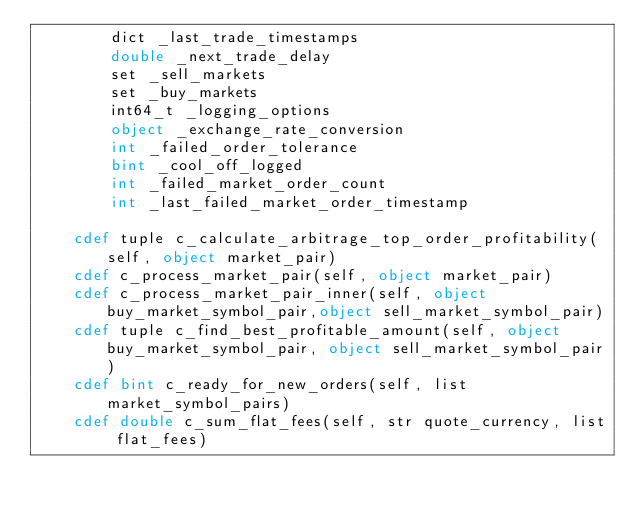<code> <loc_0><loc_0><loc_500><loc_500><_Cython_>        dict _last_trade_timestamps
        double _next_trade_delay
        set _sell_markets
        set _buy_markets
        int64_t _logging_options
        object _exchange_rate_conversion
        int _failed_order_tolerance
        bint _cool_off_logged
        int _failed_market_order_count
        int _last_failed_market_order_timestamp

    cdef tuple c_calculate_arbitrage_top_order_profitability(self, object market_pair)
    cdef c_process_market_pair(self, object market_pair)
    cdef c_process_market_pair_inner(self, object buy_market_symbol_pair,object sell_market_symbol_pair)
    cdef tuple c_find_best_profitable_amount(self, object buy_market_symbol_pair, object sell_market_symbol_pair)
    cdef bint c_ready_for_new_orders(self, list market_symbol_pairs)
    cdef double c_sum_flat_fees(self, str quote_currency, list flat_fees)
</code> 